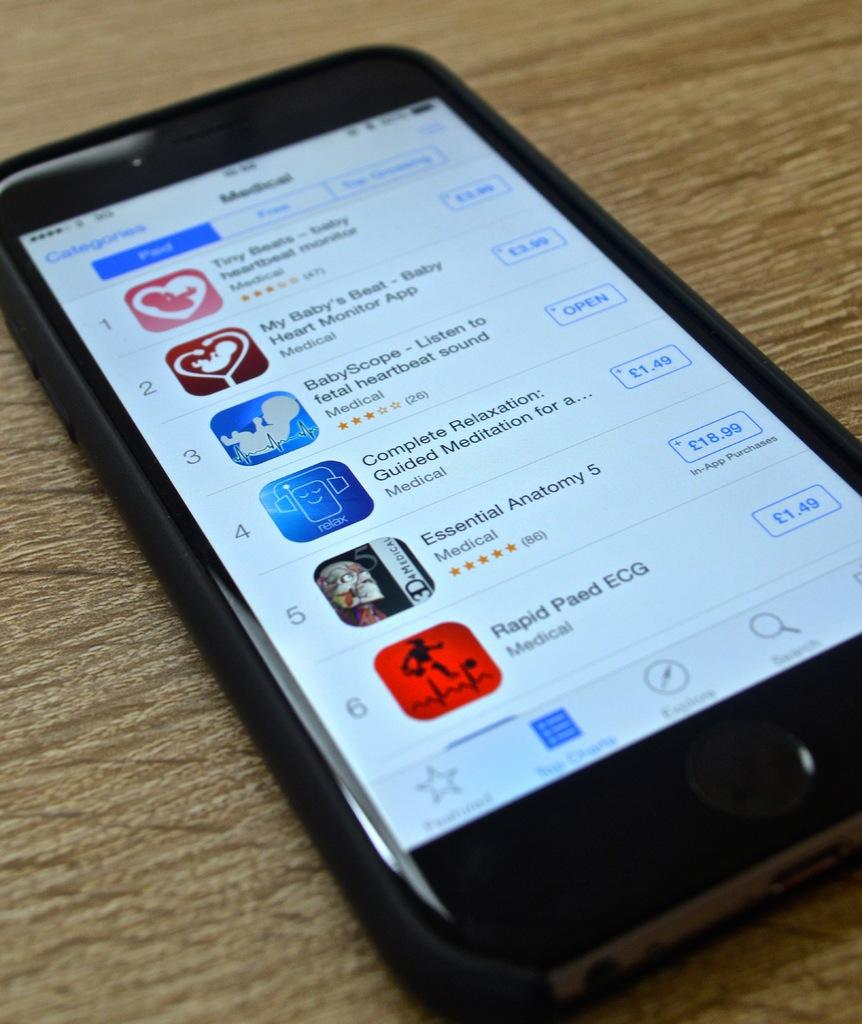<image>
Render a clear and concise summary of the photo. The front screen of a cellphone with several different apps like rapid paed ecg. 